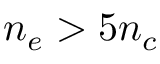<formula> <loc_0><loc_0><loc_500><loc_500>n _ { e } > 5 n _ { c }</formula> 